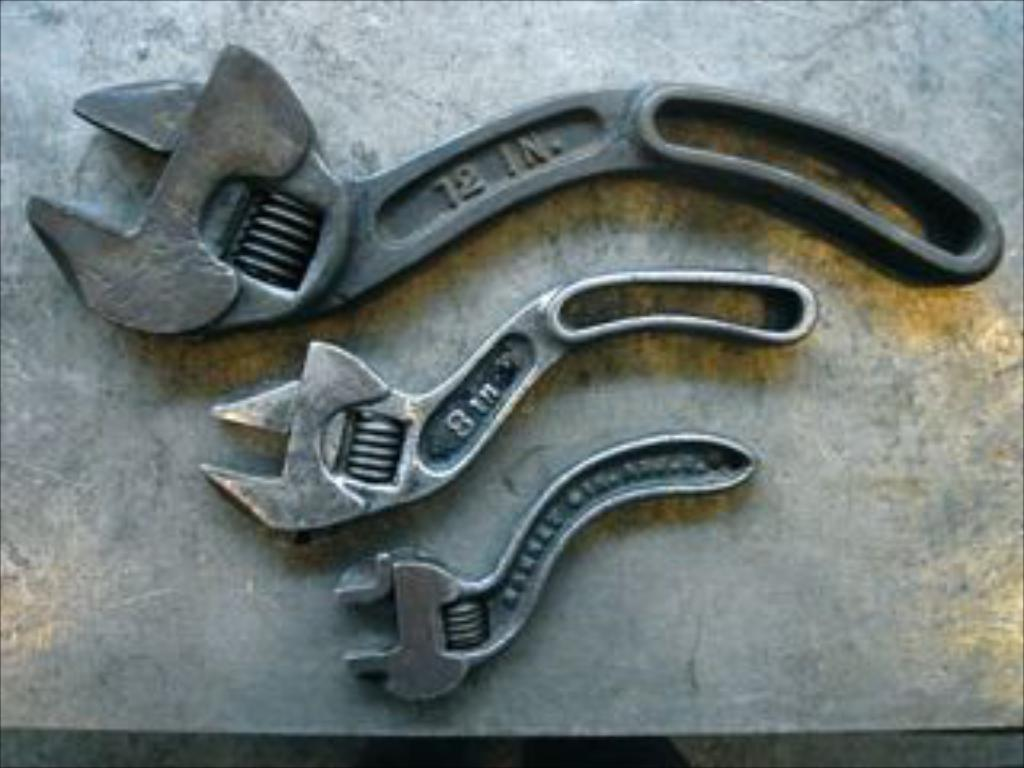What type of tools are present in the image? There are three adjustable spanners in the image. How do the spanners differ from one another? The spanners have different sizes. Where are the spanners placed in the image? The spanners are kept on a surface. What type of weather condition can be seen in the image? There is no weather condition present in the image; it features adjustable spanners on a surface. How do the bubbles affect the functionality of the spanners in the image? There are no bubbles present in the image, so their effect on the spanners cannot be determined. 